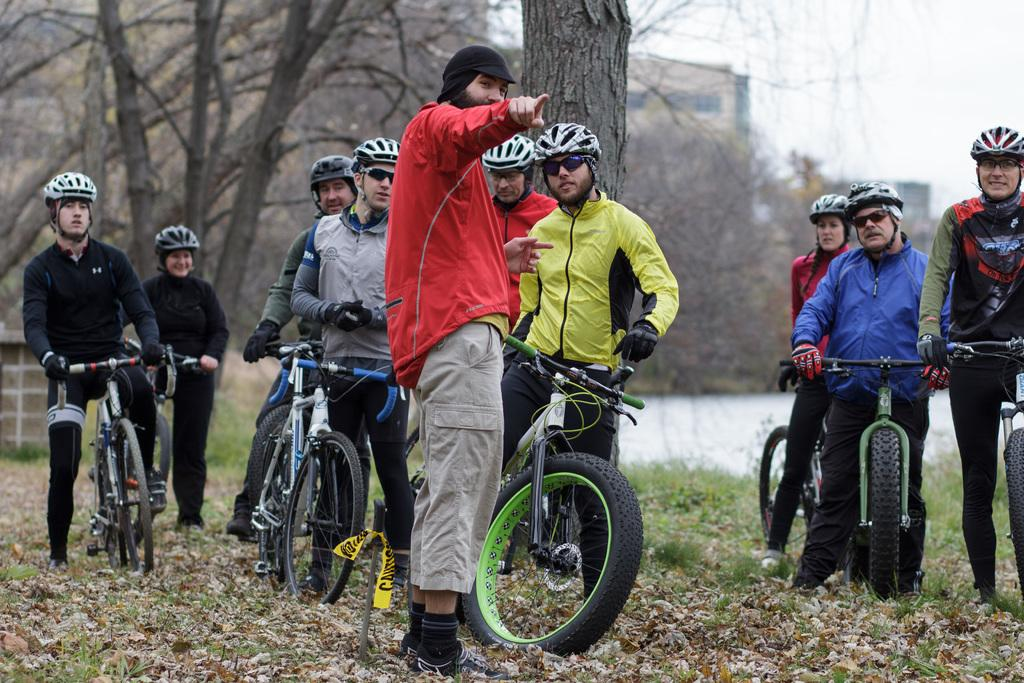What type of natural elements can be seen in the image? There are trees in the image. What type of man-made structure is present in the image? There is a building in the image. What are the people in the image doing? The people are standing and holding bicycles. Can you tell me how many friends are depicted with the people in the image? There is no mention of friends in the image; it only shows people standing and holding bicycles. What type of dog can be seen interacting with the people in the image? There is no dog present in the image; it only features people and bicycles. 